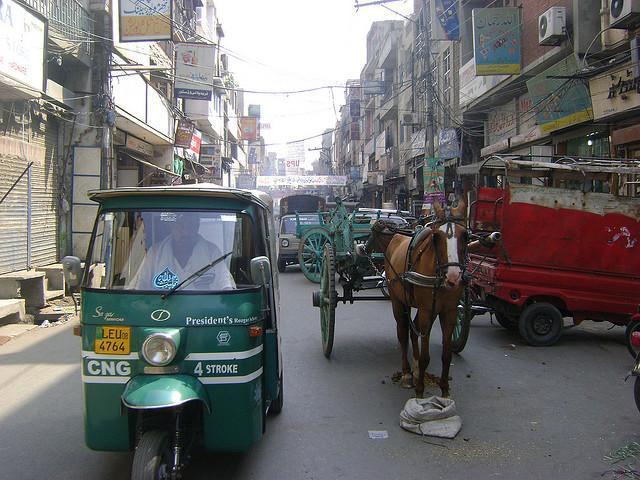How many white remotes do you see?
Give a very brief answer. 0. 